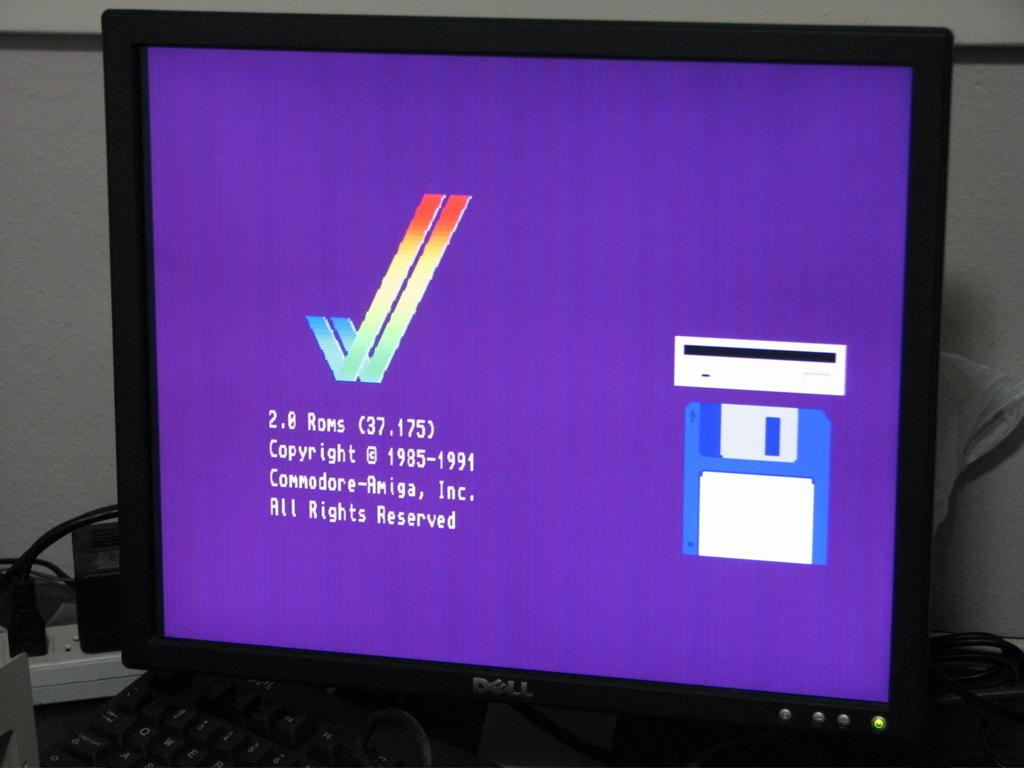Provide a one-sentence caption for the provided image. A Dell computer monitor with some copyright infor on it. 